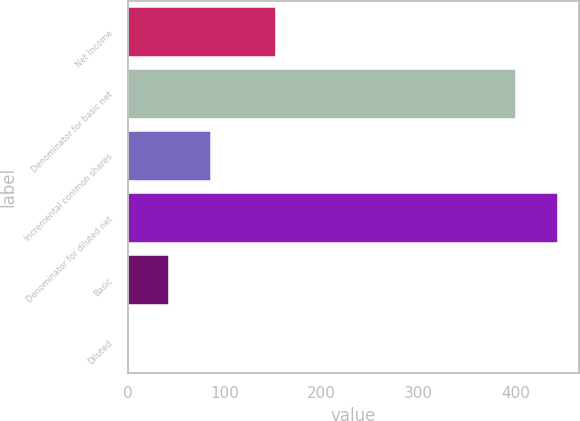Convert chart. <chart><loc_0><loc_0><loc_500><loc_500><bar_chart><fcel>Net Income<fcel>Denominator for basic net<fcel>Incremental common shares<fcel>Denominator for diluted net<fcel>Basic<fcel>Diluted<nl><fcel>153<fcel>401<fcel>85.88<fcel>443.76<fcel>43.12<fcel>0.36<nl></chart> 